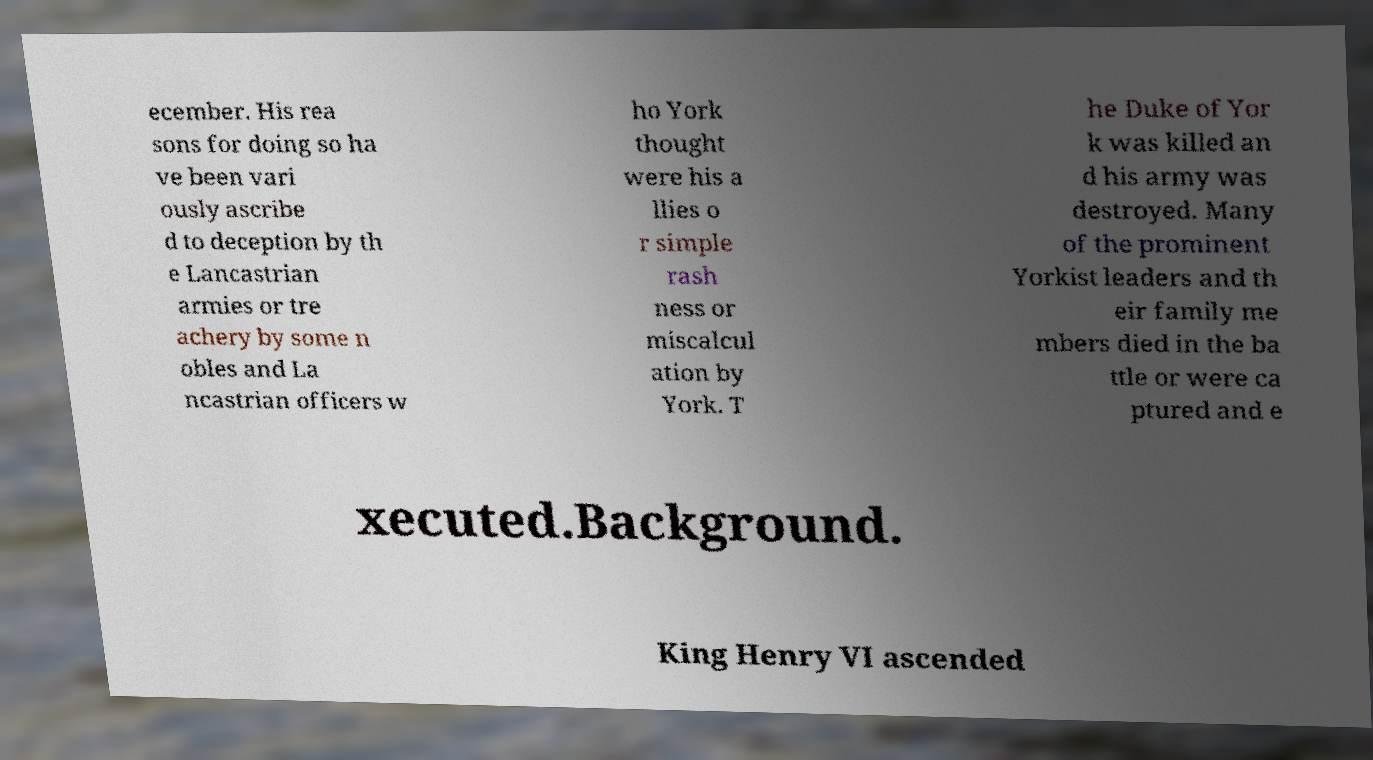What messages or text are displayed in this image? I need them in a readable, typed format. ecember. His rea sons for doing so ha ve been vari ously ascribe d to deception by th e Lancastrian armies or tre achery by some n obles and La ncastrian officers w ho York thought were his a llies o r simple rash ness or miscalcul ation by York. T he Duke of Yor k was killed an d his army was destroyed. Many of the prominent Yorkist leaders and th eir family me mbers died in the ba ttle or were ca ptured and e xecuted.Background. King Henry VI ascended 